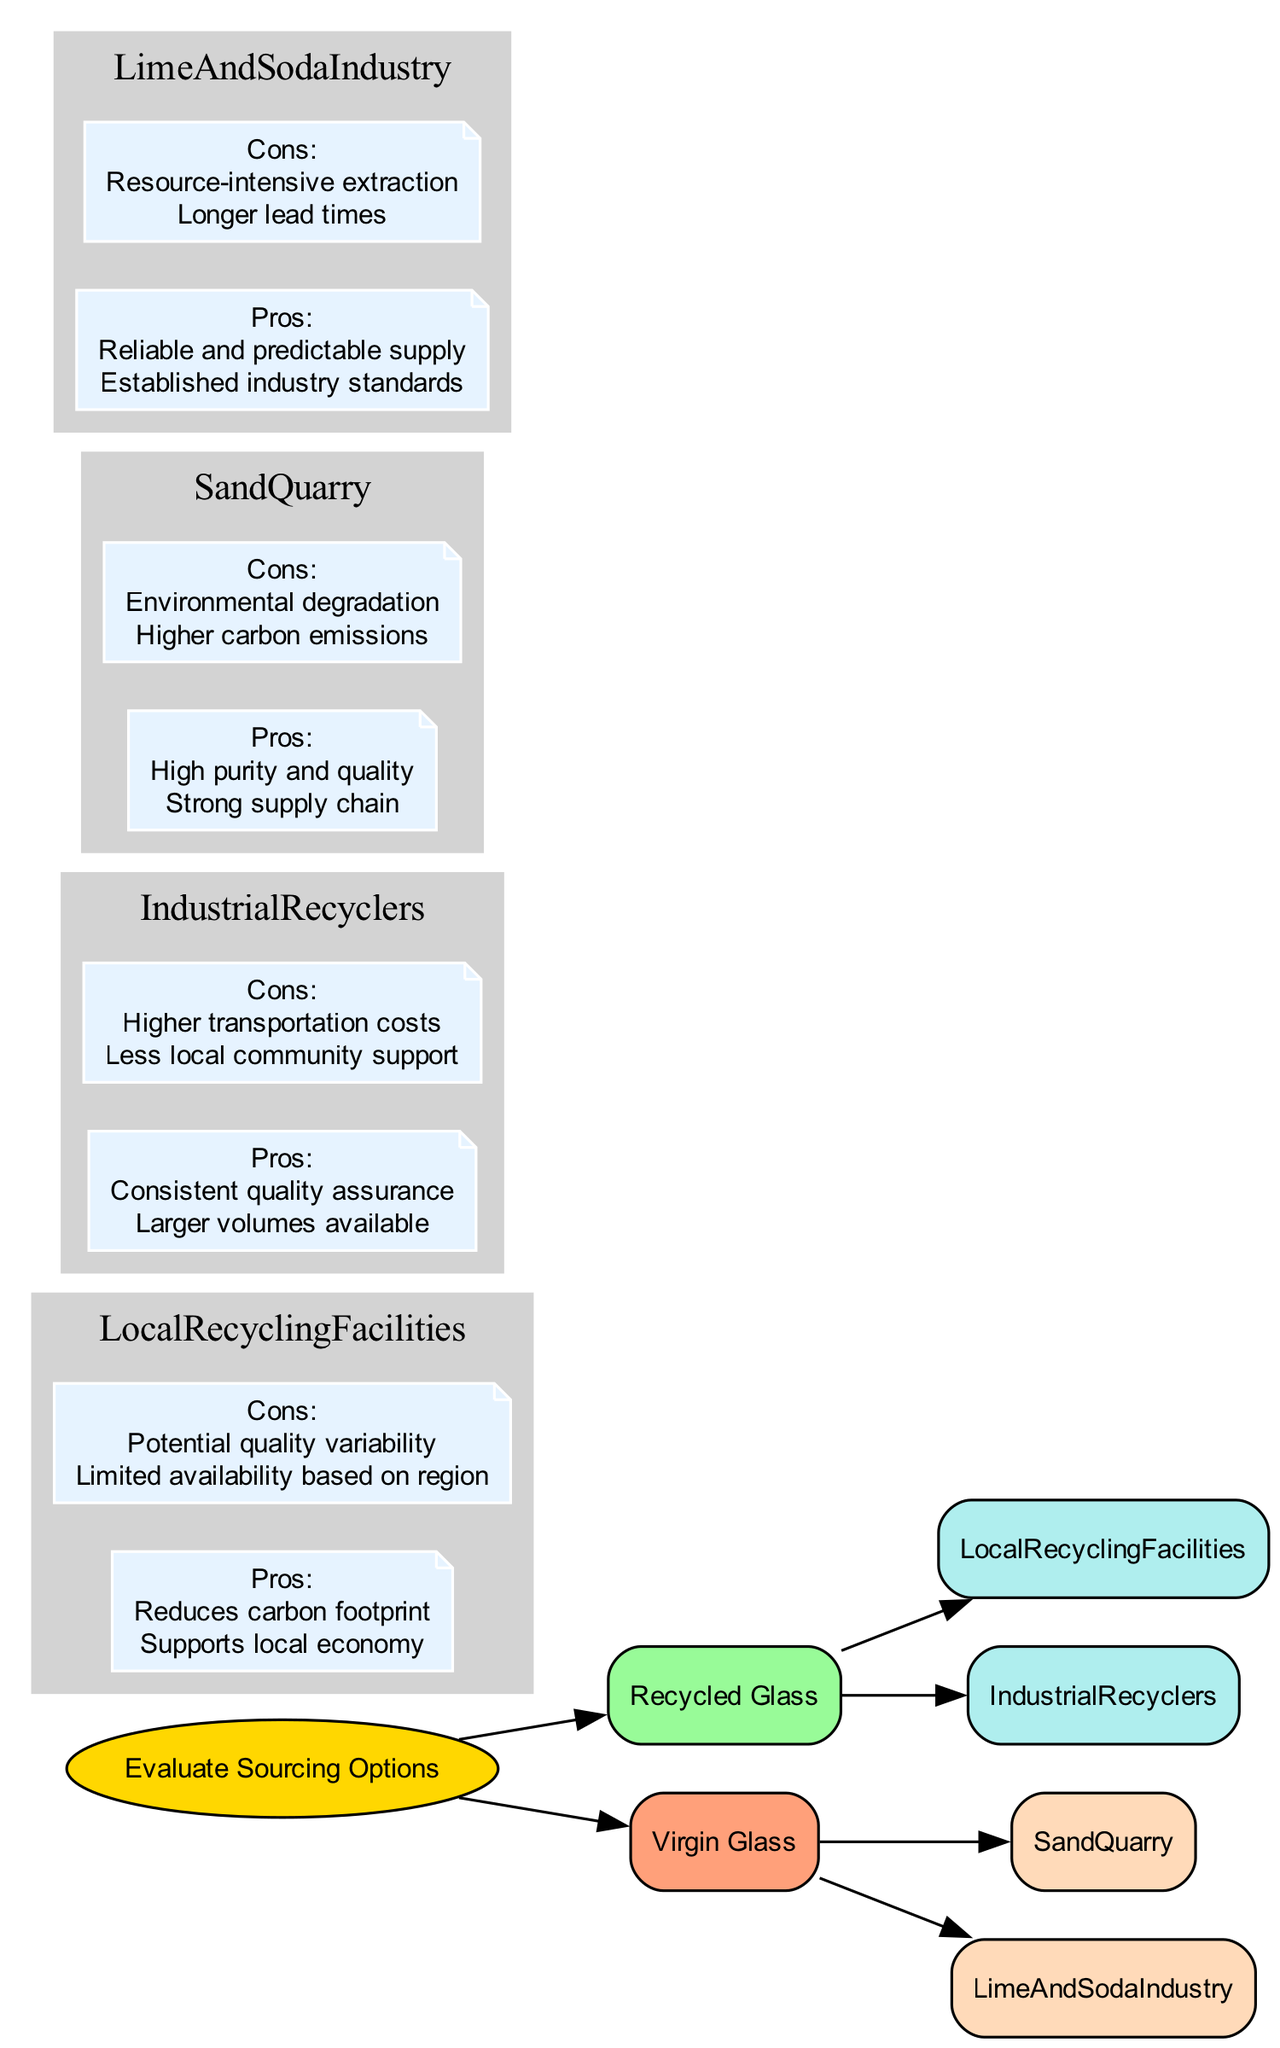What are the two main sources of glass materials evaluated in the decision tree? The decision tree presents two main branches: 'Recycled Glass' and 'Virgin Glass'. These represent the two sourcing options being evaluated for glass production.
Answer: Recycled Glass and Virgin Glass How many pros are listed for Local Recycling Facilities? In the diagram, under Local Recycling Facilities, there are two pros specified: 'Reduces carbon footprint' and 'Supports local economy'. Counting these gives the total number of pros.
Answer: 2 What is a con of using Virgin Glass sourced from Sand Quarry? One con listed for Sand Quarry under Virgin Glass is 'Environmental degradation', indicating a significant downside of sourcing from this option.
Answer: Environmental degradation Which option provides 'Consistent quality assurance'? The option 'Industrial Recyclers', under the Recycled Glass sourcing, is highlighted as offering 'Consistent quality assurance', indicating that this source may have more reliable output quality.
Answer: Industrial Recyclers What is the environmental impact associated with Virgin Glass sourced from Lime and Soda Industry? The Lime and Soda Industry option indicates 'Resource-intensive extraction' and 'Longer lead times', highlighting an environmental concern in terms of resource use and time for sourcing.
Answer: Resource-intensive extraction Which sourcing option supports the local economy? Local Recycling Facilities under the Recycled Glass branch specifically mentions 'Supports local economy' as one of its advantages, making this sourcing option beneficial to local communities.
Answer: Local Recycling Facilities How many total nodes are there in the Recycled Glass section of the diagram? In the Recycled Glass section, there are three nodes: Recycled Glass itself, Local Recycling Facilities, and Industrial Recyclers plus their respective pros and cons. Counting these gives a total of six distinct nodes.
Answer: 6 What is a disadvantage of using Industrial Recyclers? The disadvantage identified for Industrial Recyclers is 'Higher transportation costs', suggesting an increase in expenses associated with sourcing this way.
Answer: Higher transportation costs What is a pro of sourcing from Sand Quarry? A pro of sourcing from Sand Quarry under Virgin Glass is 'High purity and quality', indicating a significant advantage of using this material.
Answer: High purity and quality 